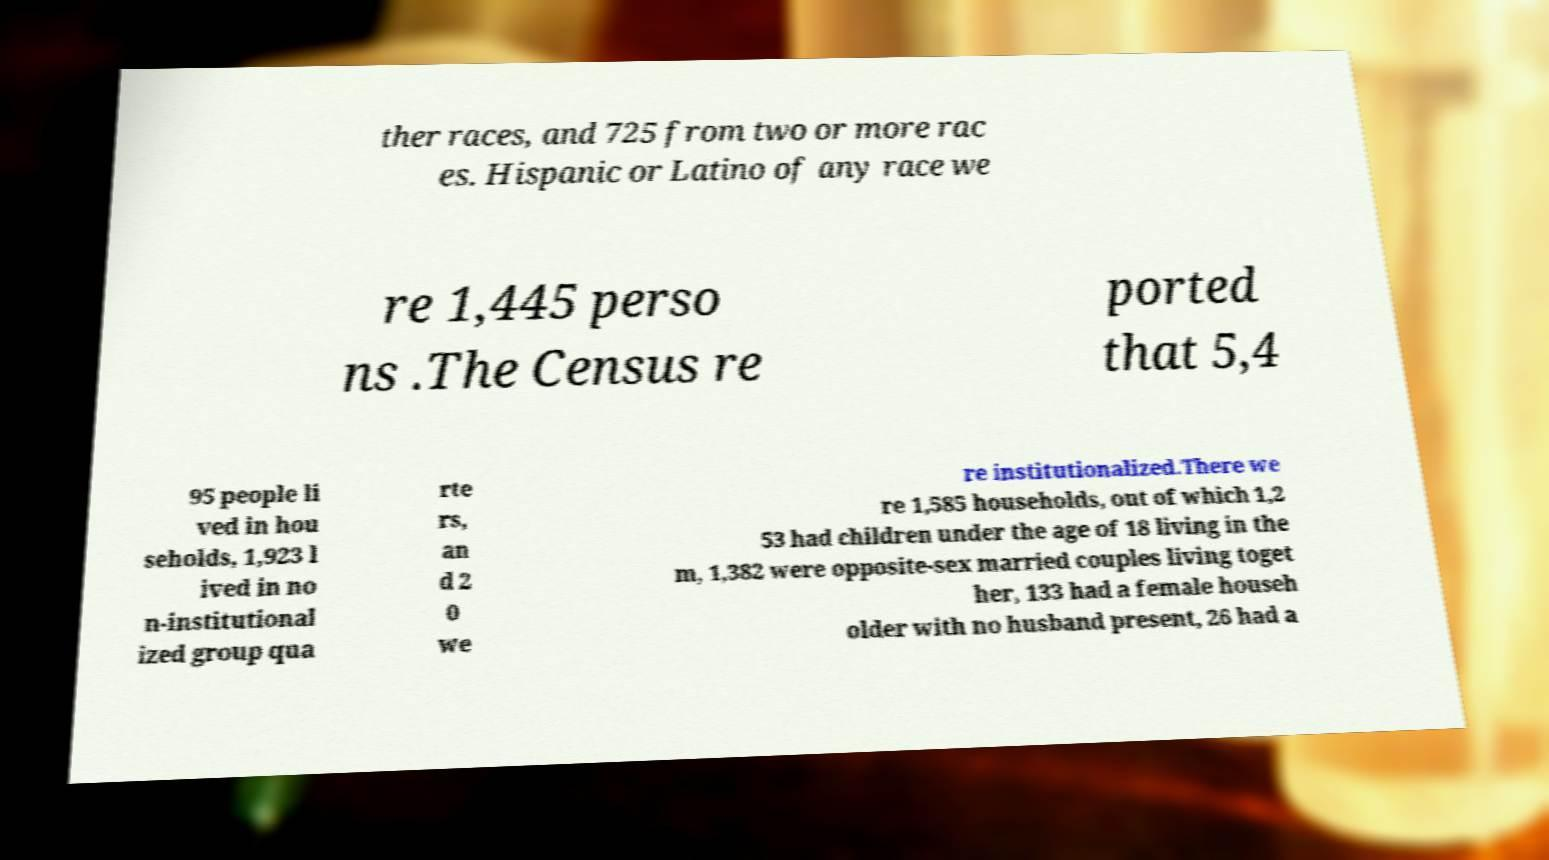Please identify and transcribe the text found in this image. ther races, and 725 from two or more rac es. Hispanic or Latino of any race we re 1,445 perso ns .The Census re ported that 5,4 95 people li ved in hou seholds, 1,923 l ived in no n-institutional ized group qua rte rs, an d 2 0 we re institutionalized.There we re 1,585 households, out of which 1,2 53 had children under the age of 18 living in the m, 1,382 were opposite-sex married couples living toget her, 133 had a female househ older with no husband present, 26 had a 